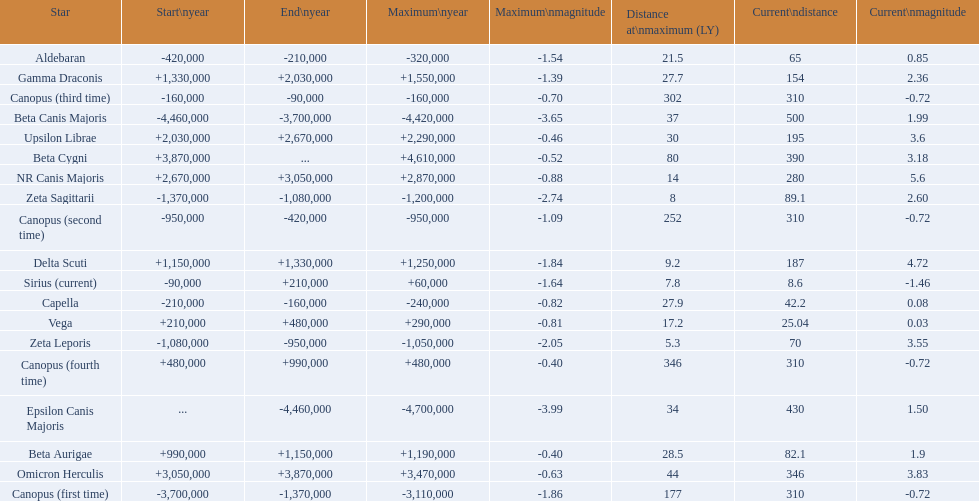What are all the stars? Epsilon Canis Majoris, Beta Canis Majoris, Canopus (first time), Zeta Sagittarii, Zeta Leporis, Canopus (second time), Aldebaran, Capella, Canopus (third time), Sirius (current), Vega, Canopus (fourth time), Beta Aurigae, Delta Scuti, Gamma Draconis, Upsilon Librae, NR Canis Majoris, Omicron Herculis, Beta Cygni. Of those, which star has a maximum distance of 80? Beta Cygni. 